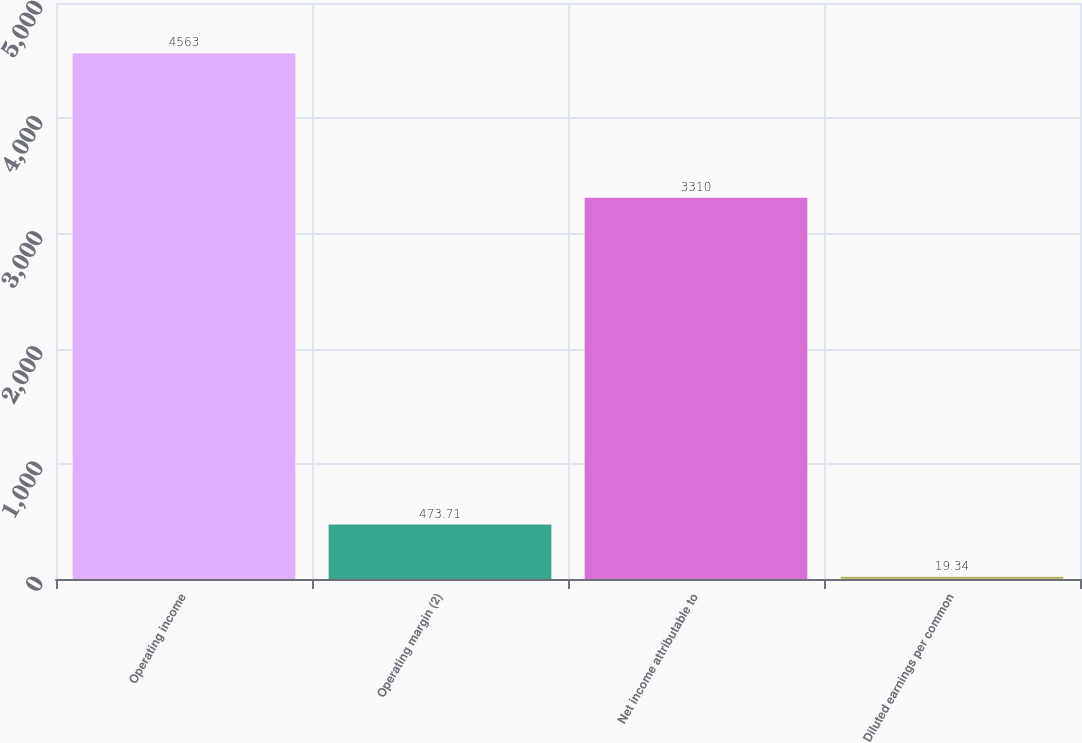<chart> <loc_0><loc_0><loc_500><loc_500><bar_chart><fcel>Operating income<fcel>Operating margin (2)<fcel>Net income attributable to<fcel>Diluted earnings per common<nl><fcel>4563<fcel>473.71<fcel>3310<fcel>19.34<nl></chart> 